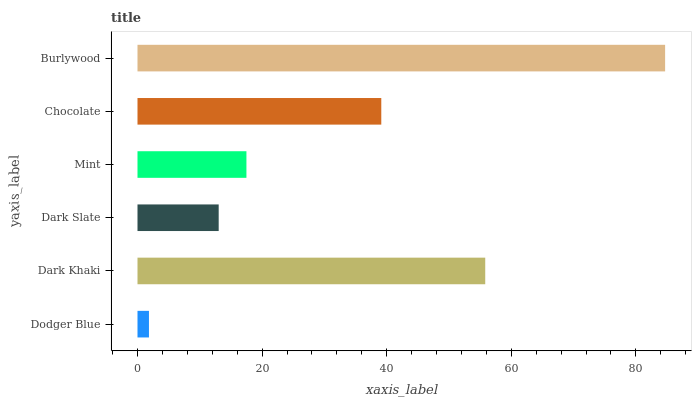Is Dodger Blue the minimum?
Answer yes or no. Yes. Is Burlywood the maximum?
Answer yes or no. Yes. Is Dark Khaki the minimum?
Answer yes or no. No. Is Dark Khaki the maximum?
Answer yes or no. No. Is Dark Khaki greater than Dodger Blue?
Answer yes or no. Yes. Is Dodger Blue less than Dark Khaki?
Answer yes or no. Yes. Is Dodger Blue greater than Dark Khaki?
Answer yes or no. No. Is Dark Khaki less than Dodger Blue?
Answer yes or no. No. Is Chocolate the high median?
Answer yes or no. Yes. Is Mint the low median?
Answer yes or no. Yes. Is Dodger Blue the high median?
Answer yes or no. No. Is Dark Slate the low median?
Answer yes or no. No. 